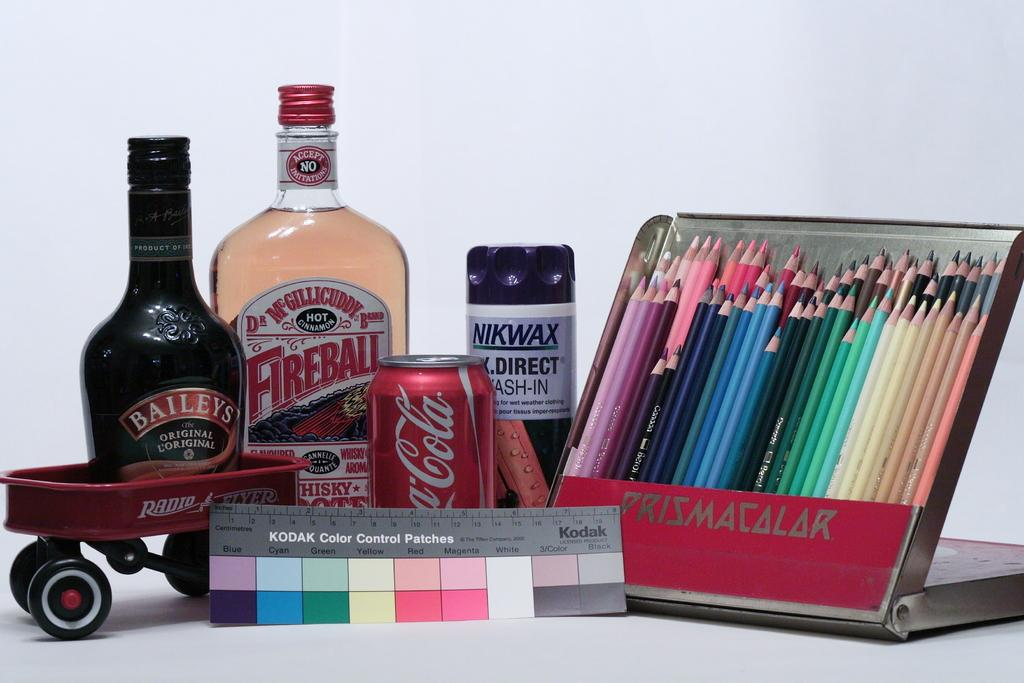<image>
Write a terse but informative summary of the picture. A can of Coca Cola sits on display near a Radio Flyer wagon 